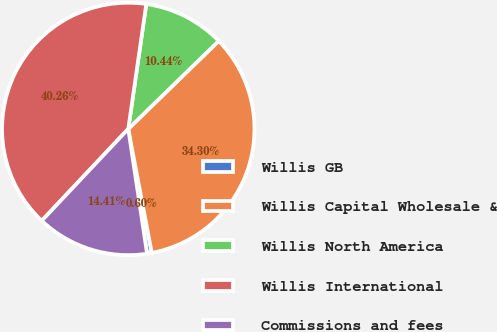Convert chart to OTSL. <chart><loc_0><loc_0><loc_500><loc_500><pie_chart><fcel>Willis GB<fcel>Willis Capital Wholesale &<fcel>Willis North America<fcel>Willis International<fcel>Commissions and fees<nl><fcel>0.6%<fcel>34.3%<fcel>10.44%<fcel>40.26%<fcel>14.41%<nl></chart> 